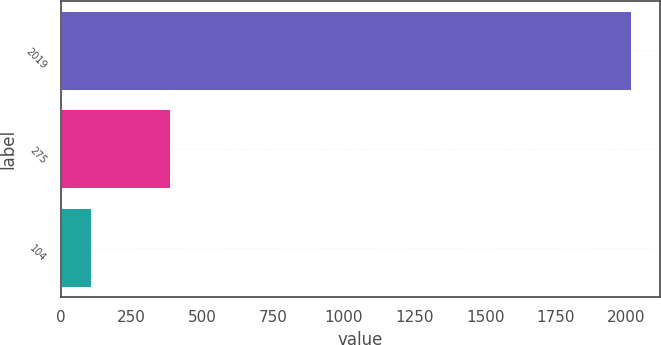<chart> <loc_0><loc_0><loc_500><loc_500><bar_chart><fcel>2019<fcel>275<fcel>104<nl><fcel>2017<fcel>384<fcel>107<nl></chart> 